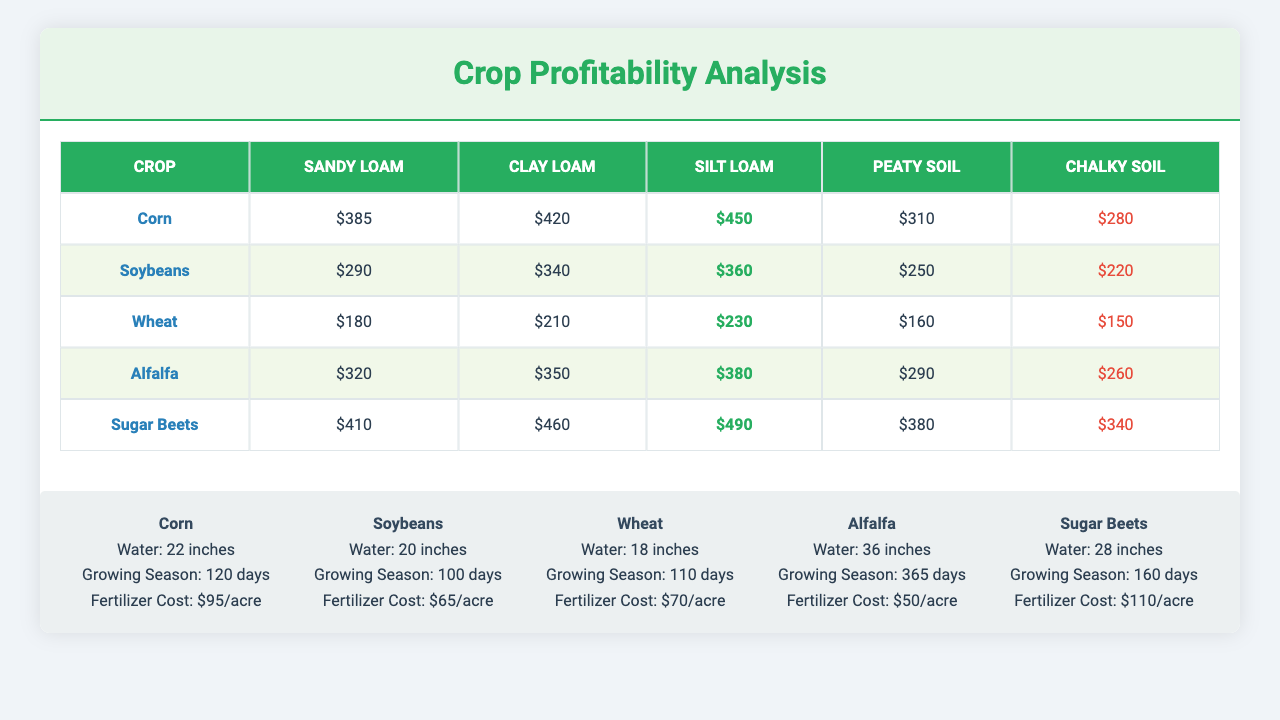What is the profit per acre for corn in Sandy Loam soil? According to the table, the profit per acre for corn in Sandy Loam soil is $385.
Answer: $385 Which crop generates the highest profit per acre in Silt Loam soil? The table shows that Sugar Beets generates the highest profit per acre, which is $490 in Silt Loam soil.
Answer: Sugar Beets What is the water requirement in inches for Alfalfa? Alfalfa requires 36 inches of water, as stated in the additional information section of the table.
Answer: 36 inches Which crop has the lowest profit per acre in Chalky Soil? Upon reviewing the table, Wheat has the lowest profit per acre in Chalky Soil at $150.
Answer: Wheat How does the profit per acre of corn in Clay Loam compare to that of soybeans in the same soil type? The profit per acre for corn in Clay Loam is $420, while for soybeans it is $340. The difference is $420 - $340 = $80, indicating corn is more profitable by $80.
Answer: Corn is more profitable by $80 What is the average profit per acre for all crops in Peaty Soil? The profits per acre for each crop in Peaty Soil is: Corn ($310), Soybeans ($250), Wheat ($160), Alfalfa ($290), Sugar Beets ($380). Summing these gives $310 + $250 + $160 + $290 + $380 = $1390, and dividing by 5 yields an average of $1390 / 5 = $278.
Answer: $278 Is the growing season for corn longer than that for soybeans? From the information in the table, corn has a growing season of 120 days, while soybeans have 100 days. Therefore, corn has a longer growing season.
Answer: Yes Which crop has the least water requirement and what is its value? The table shows that wheat has the least water requirement at 18 inches.
Answer: Wheat, 18 inches What is the difference between the fertilizer cost per acre for corn and sugar beets? The cost for corn is $95 and for sugar beets it is $110. The difference is $110 - $95 = $15, indicating that sugar beets require $15 more in fertilizer.
Answer: $15 Which crop offers the highest profitability in Clay Loam soil? The table indicates that Sugar Beets offers the highest profitability in Clay Loam soil with a profit of $460 per acre.
Answer: Sugar Beets If I want to maximize profits focusing on Sandy Loam soil, which two crops should I consider? In Sandy Loam soil, the profits are $385 for corn and $410 for sugar beets. Therefore, I should consider sugar beets and corn to maximize profits.
Answer: Sugar Beets and Corn 